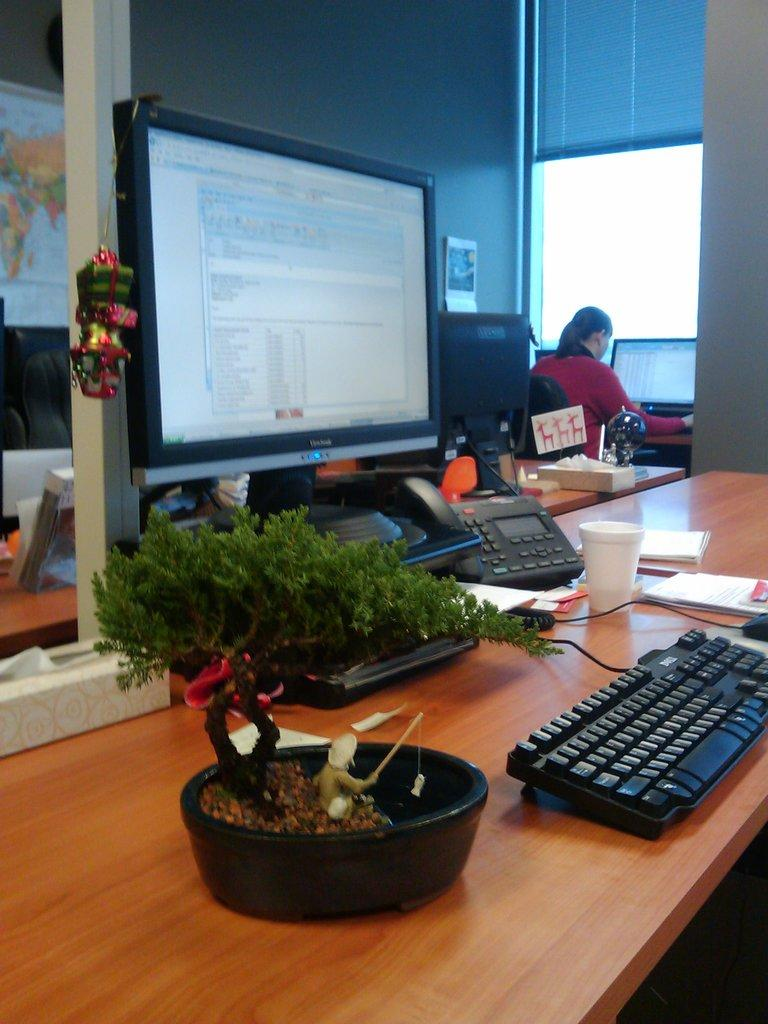What type of furniture is present in the image? There is a table in the image. What is on the table? The table has a desktop, a keyboard, a cup, a book, and a plant. Can you describe the person in the background of the image? The person is wearing a red dress and is sitting in a chair. What is the person doing in the image? The person is looking at the desktop. What news is being reported on the example in the middle of the image? There is no news or example present in the image; it only features a table with various items and a person in the background. 